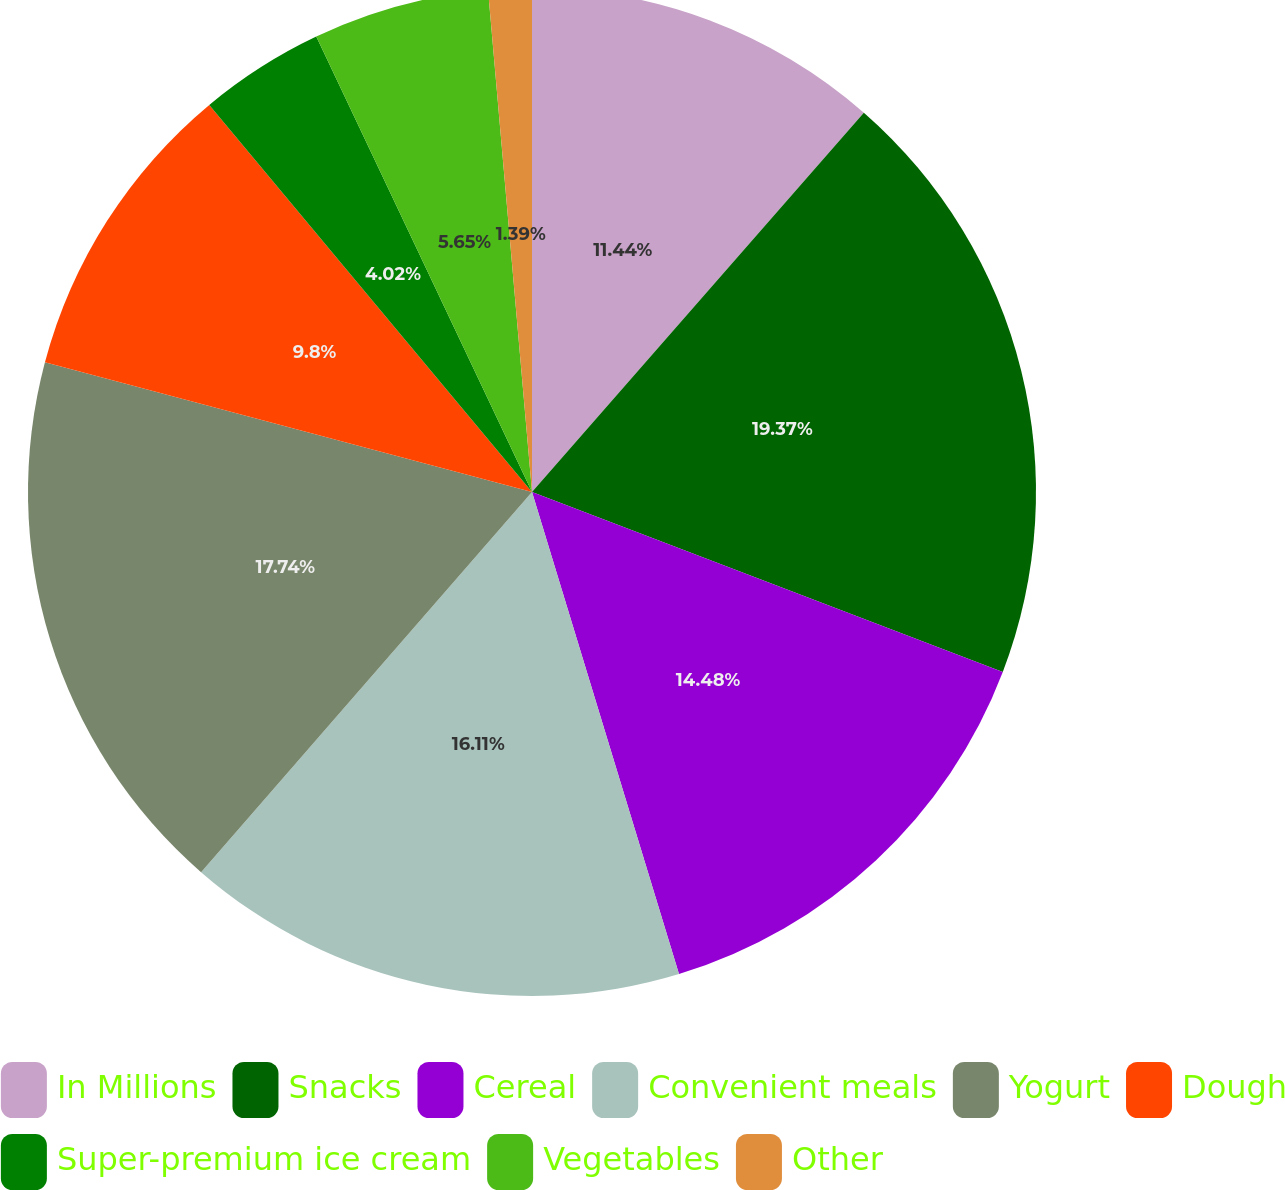Convert chart. <chart><loc_0><loc_0><loc_500><loc_500><pie_chart><fcel>In Millions<fcel>Snacks<fcel>Cereal<fcel>Convenient meals<fcel>Yogurt<fcel>Dough<fcel>Super-premium ice cream<fcel>Vegetables<fcel>Other<nl><fcel>11.44%<fcel>19.37%<fcel>14.48%<fcel>16.11%<fcel>17.74%<fcel>9.8%<fcel>4.02%<fcel>5.65%<fcel>1.39%<nl></chart> 